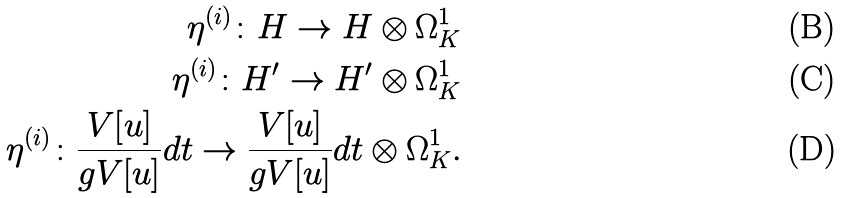Convert formula to latex. <formula><loc_0><loc_0><loc_500><loc_500>\eta ^ { ( i ) } \colon H \to H \otimes \Omega ^ { 1 } _ { K } \\ \eta ^ { ( i ) } \colon H ^ { \prime } \to H ^ { \prime } \otimes \Omega ^ { 1 } _ { K } \\ \eta ^ { ( i ) } \colon \frac { V [ u ] } { g V [ u ] } d t \to \frac { V [ u ] } { g V [ u ] } d t \otimes \Omega ^ { 1 } _ { K } .</formula> 